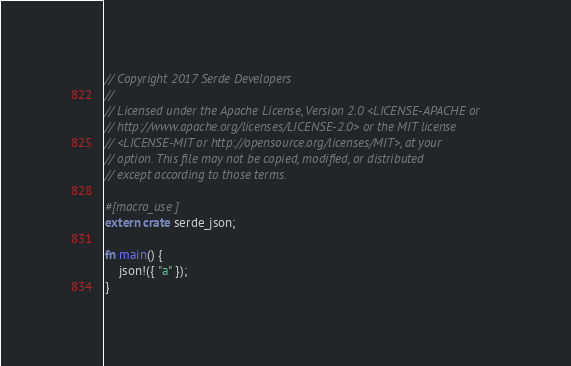Convert code to text. <code><loc_0><loc_0><loc_500><loc_500><_Rust_>// Copyright 2017 Serde Developers
//
// Licensed under the Apache License, Version 2.0 <LICENSE-APACHE or
// http://www.apache.org/licenses/LICENSE-2.0> or the MIT license
// <LICENSE-MIT or http://opensource.org/licenses/MIT>, at your
// option. This file may not be copied, modified, or distributed
// except according to those terms.

#[macro_use]
extern crate serde_json;

fn main() {
    json!({ "a" });
}
</code> 